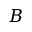Convert formula to latex. <formula><loc_0><loc_0><loc_500><loc_500>B</formula> 